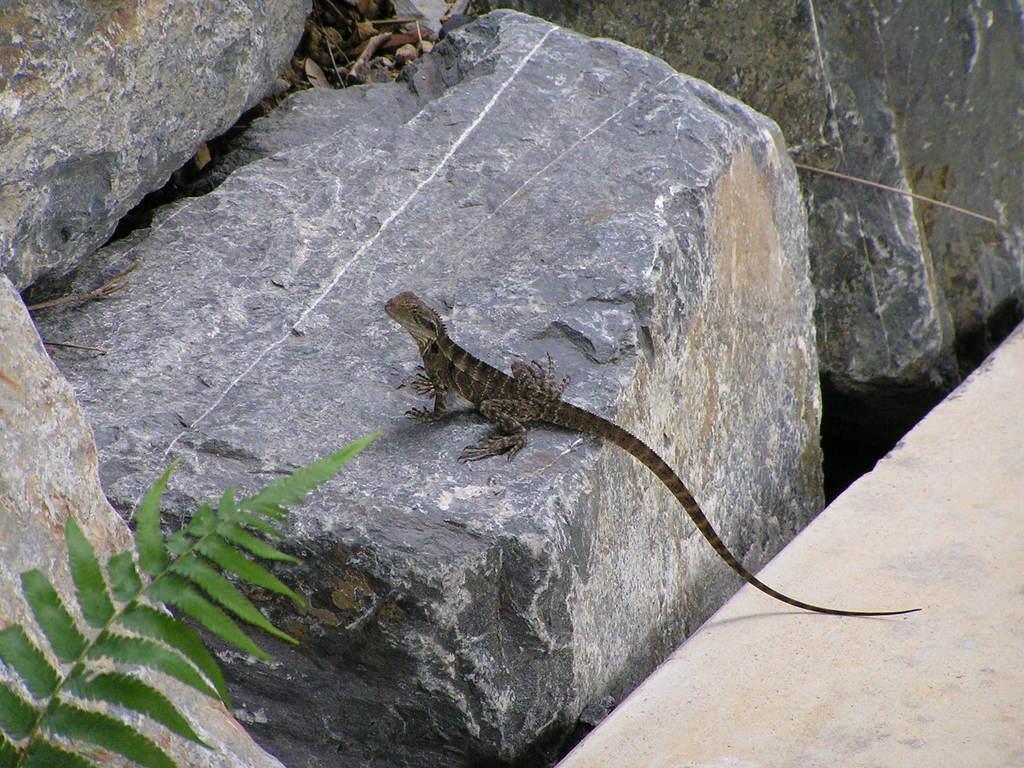Please provide a concise description of this image. This image is taken outdoors. On the right side of the image there is a floor. On the left side of the image there is a plant with green leaves and stems. In the middle of the image there are a few rocks and there is a reptile on the rock. 